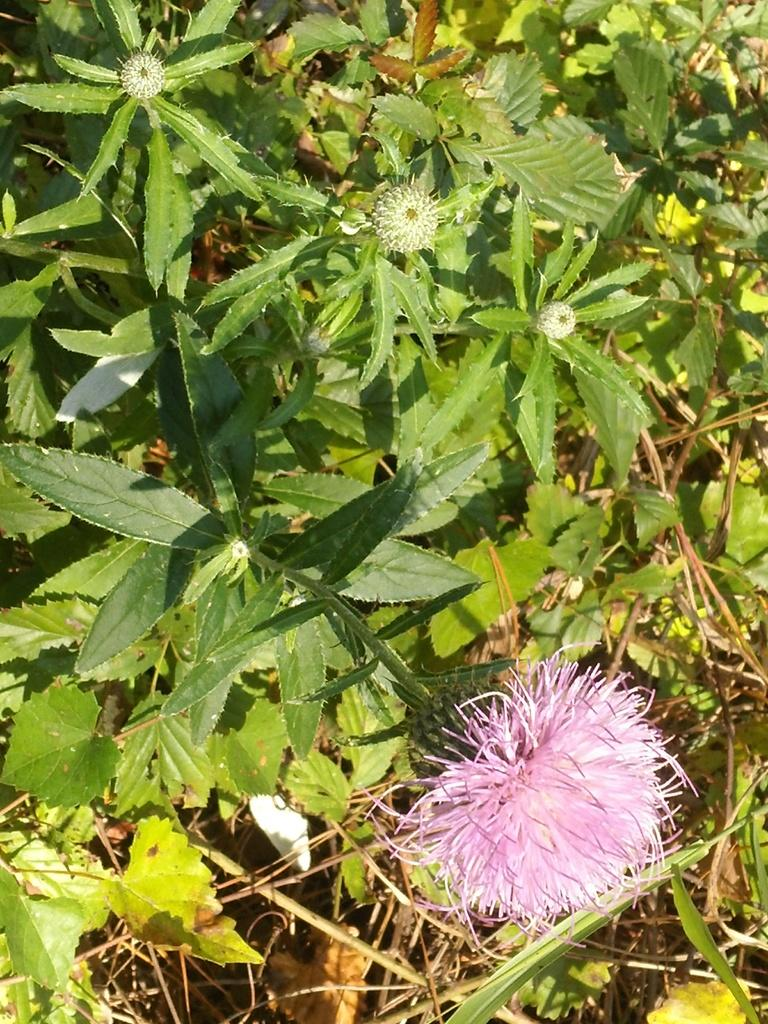What is present in the image? There is a flower in the image. Can you describe the color of the flower? The flower is pink in color. Are there any other flowers in the image besides the pink one? Yes, there are bud flowers in the image. What else can be seen in the image besides flowers? There are leaves in the image. How many times does the flower scene change in the image? The image does not depict a scene that changes; it is a static image of a flower. What type of fabric is the silk used for the flower in the image? The image does not depict a flower made of silk; it is a photograph or illustration of a real flower. 